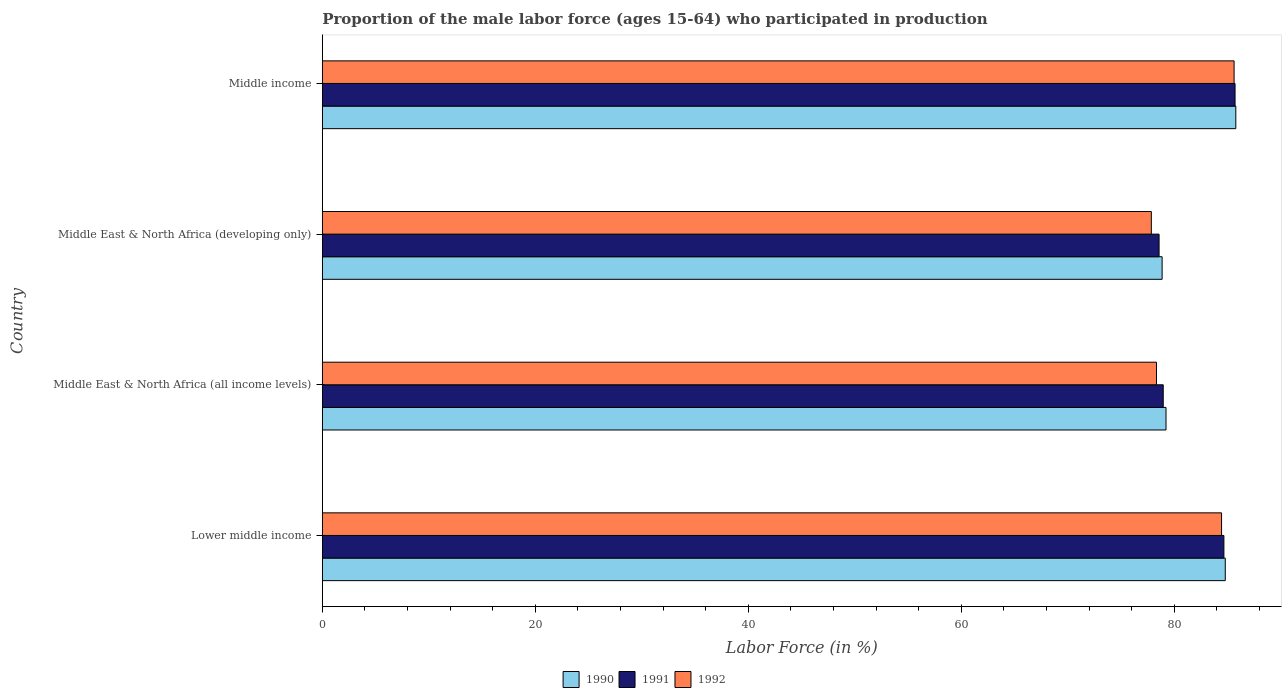How many different coloured bars are there?
Provide a succinct answer. 3. How many groups of bars are there?
Your answer should be compact. 4. Are the number of bars per tick equal to the number of legend labels?
Provide a succinct answer. Yes. Are the number of bars on each tick of the Y-axis equal?
Your response must be concise. Yes. How many bars are there on the 2nd tick from the bottom?
Give a very brief answer. 3. What is the label of the 2nd group of bars from the top?
Your answer should be compact. Middle East & North Africa (developing only). What is the proportion of the male labor force who participated in production in 1992 in Middle East & North Africa (developing only)?
Provide a succinct answer. 77.85. Across all countries, what is the maximum proportion of the male labor force who participated in production in 1990?
Offer a terse response. 85.78. Across all countries, what is the minimum proportion of the male labor force who participated in production in 1991?
Ensure brevity in your answer.  78.57. In which country was the proportion of the male labor force who participated in production in 1991 maximum?
Give a very brief answer. Middle income. In which country was the proportion of the male labor force who participated in production in 1992 minimum?
Your answer should be compact. Middle East & North Africa (developing only). What is the total proportion of the male labor force who participated in production in 1992 in the graph?
Give a very brief answer. 326.23. What is the difference between the proportion of the male labor force who participated in production in 1992 in Middle East & North Africa (all income levels) and that in Middle income?
Your answer should be compact. -7.29. What is the difference between the proportion of the male labor force who participated in production in 1991 in Middle income and the proportion of the male labor force who participated in production in 1992 in Middle East & North Africa (developing only)?
Keep it short and to the point. 7.86. What is the average proportion of the male labor force who participated in production in 1990 per country?
Make the answer very short. 82.16. What is the difference between the proportion of the male labor force who participated in production in 1992 and proportion of the male labor force who participated in production in 1990 in Middle East & North Africa (developing only)?
Your answer should be very brief. -1.01. What is the ratio of the proportion of the male labor force who participated in production in 1991 in Lower middle income to that in Middle East & North Africa (developing only)?
Ensure brevity in your answer.  1.08. What is the difference between the highest and the second highest proportion of the male labor force who participated in production in 1991?
Ensure brevity in your answer.  1.05. What is the difference between the highest and the lowest proportion of the male labor force who participated in production in 1991?
Your answer should be compact. 7.13. In how many countries, is the proportion of the male labor force who participated in production in 1992 greater than the average proportion of the male labor force who participated in production in 1992 taken over all countries?
Your answer should be very brief. 2. Is the sum of the proportion of the male labor force who participated in production in 1990 in Lower middle income and Middle East & North Africa (all income levels) greater than the maximum proportion of the male labor force who participated in production in 1991 across all countries?
Ensure brevity in your answer.  Yes. Are all the bars in the graph horizontal?
Make the answer very short. Yes. What is the difference between two consecutive major ticks on the X-axis?
Your answer should be very brief. 20. Does the graph contain any zero values?
Make the answer very short. No. Does the graph contain grids?
Your answer should be compact. No. Where does the legend appear in the graph?
Make the answer very short. Bottom center. How many legend labels are there?
Ensure brevity in your answer.  3. What is the title of the graph?
Offer a terse response. Proportion of the male labor force (ages 15-64) who participated in production. Does "1994" appear as one of the legend labels in the graph?
Provide a succinct answer. No. What is the label or title of the X-axis?
Your answer should be compact. Labor Force (in %). What is the label or title of the Y-axis?
Make the answer very short. Country. What is the Labor Force (in %) of 1990 in Lower middle income?
Offer a very short reply. 84.79. What is the Labor Force (in %) in 1991 in Lower middle income?
Your response must be concise. 84.66. What is the Labor Force (in %) in 1992 in Lower middle income?
Provide a succinct answer. 84.44. What is the Labor Force (in %) in 1990 in Middle East & North Africa (all income levels)?
Your answer should be very brief. 79.22. What is the Labor Force (in %) in 1991 in Middle East & North Africa (all income levels)?
Provide a succinct answer. 78.96. What is the Labor Force (in %) in 1992 in Middle East & North Africa (all income levels)?
Your answer should be very brief. 78.33. What is the Labor Force (in %) in 1990 in Middle East & North Africa (developing only)?
Make the answer very short. 78.86. What is the Labor Force (in %) in 1991 in Middle East & North Africa (developing only)?
Provide a short and direct response. 78.57. What is the Labor Force (in %) in 1992 in Middle East & North Africa (developing only)?
Your response must be concise. 77.85. What is the Labor Force (in %) of 1990 in Middle income?
Ensure brevity in your answer.  85.78. What is the Labor Force (in %) of 1991 in Middle income?
Your answer should be very brief. 85.71. What is the Labor Force (in %) of 1992 in Middle income?
Offer a very short reply. 85.62. Across all countries, what is the maximum Labor Force (in %) of 1990?
Ensure brevity in your answer.  85.78. Across all countries, what is the maximum Labor Force (in %) in 1991?
Offer a terse response. 85.71. Across all countries, what is the maximum Labor Force (in %) of 1992?
Give a very brief answer. 85.62. Across all countries, what is the minimum Labor Force (in %) in 1990?
Ensure brevity in your answer.  78.86. Across all countries, what is the minimum Labor Force (in %) of 1991?
Your response must be concise. 78.57. Across all countries, what is the minimum Labor Force (in %) of 1992?
Your answer should be very brief. 77.85. What is the total Labor Force (in %) of 1990 in the graph?
Your answer should be very brief. 328.65. What is the total Labor Force (in %) of 1991 in the graph?
Offer a very short reply. 327.9. What is the total Labor Force (in %) of 1992 in the graph?
Provide a short and direct response. 326.23. What is the difference between the Labor Force (in %) in 1990 in Lower middle income and that in Middle East & North Africa (all income levels)?
Your answer should be very brief. 5.56. What is the difference between the Labor Force (in %) of 1991 in Lower middle income and that in Middle East & North Africa (all income levels)?
Make the answer very short. 5.7. What is the difference between the Labor Force (in %) in 1992 in Lower middle income and that in Middle East & North Africa (all income levels)?
Provide a succinct answer. 6.11. What is the difference between the Labor Force (in %) in 1990 in Lower middle income and that in Middle East & North Africa (developing only)?
Give a very brief answer. 5.93. What is the difference between the Labor Force (in %) in 1991 in Lower middle income and that in Middle East & North Africa (developing only)?
Provide a short and direct response. 6.09. What is the difference between the Labor Force (in %) in 1992 in Lower middle income and that in Middle East & North Africa (developing only)?
Your answer should be compact. 6.59. What is the difference between the Labor Force (in %) of 1990 in Lower middle income and that in Middle income?
Make the answer very short. -0.99. What is the difference between the Labor Force (in %) in 1991 in Lower middle income and that in Middle income?
Your answer should be compact. -1.05. What is the difference between the Labor Force (in %) of 1992 in Lower middle income and that in Middle income?
Your response must be concise. -1.18. What is the difference between the Labor Force (in %) of 1990 in Middle East & North Africa (all income levels) and that in Middle East & North Africa (developing only)?
Give a very brief answer. 0.37. What is the difference between the Labor Force (in %) in 1991 in Middle East & North Africa (all income levels) and that in Middle East & North Africa (developing only)?
Offer a very short reply. 0.39. What is the difference between the Labor Force (in %) in 1992 in Middle East & North Africa (all income levels) and that in Middle East & North Africa (developing only)?
Your response must be concise. 0.48. What is the difference between the Labor Force (in %) of 1990 in Middle East & North Africa (all income levels) and that in Middle income?
Your answer should be compact. -6.55. What is the difference between the Labor Force (in %) of 1991 in Middle East & North Africa (all income levels) and that in Middle income?
Your response must be concise. -6.74. What is the difference between the Labor Force (in %) of 1992 in Middle East & North Africa (all income levels) and that in Middle income?
Provide a succinct answer. -7.29. What is the difference between the Labor Force (in %) of 1990 in Middle East & North Africa (developing only) and that in Middle income?
Give a very brief answer. -6.92. What is the difference between the Labor Force (in %) of 1991 in Middle East & North Africa (developing only) and that in Middle income?
Provide a succinct answer. -7.13. What is the difference between the Labor Force (in %) of 1992 in Middle East & North Africa (developing only) and that in Middle income?
Keep it short and to the point. -7.77. What is the difference between the Labor Force (in %) in 1990 in Lower middle income and the Labor Force (in %) in 1991 in Middle East & North Africa (all income levels)?
Your response must be concise. 5.82. What is the difference between the Labor Force (in %) of 1990 in Lower middle income and the Labor Force (in %) of 1992 in Middle East & North Africa (all income levels)?
Ensure brevity in your answer.  6.46. What is the difference between the Labor Force (in %) of 1991 in Lower middle income and the Labor Force (in %) of 1992 in Middle East & North Africa (all income levels)?
Offer a very short reply. 6.33. What is the difference between the Labor Force (in %) in 1990 in Lower middle income and the Labor Force (in %) in 1991 in Middle East & North Africa (developing only)?
Provide a short and direct response. 6.22. What is the difference between the Labor Force (in %) in 1990 in Lower middle income and the Labor Force (in %) in 1992 in Middle East & North Africa (developing only)?
Provide a succinct answer. 6.94. What is the difference between the Labor Force (in %) in 1991 in Lower middle income and the Labor Force (in %) in 1992 in Middle East & North Africa (developing only)?
Provide a succinct answer. 6.81. What is the difference between the Labor Force (in %) of 1990 in Lower middle income and the Labor Force (in %) of 1991 in Middle income?
Provide a succinct answer. -0.92. What is the difference between the Labor Force (in %) in 1990 in Lower middle income and the Labor Force (in %) in 1992 in Middle income?
Give a very brief answer. -0.83. What is the difference between the Labor Force (in %) of 1991 in Lower middle income and the Labor Force (in %) of 1992 in Middle income?
Ensure brevity in your answer.  -0.96. What is the difference between the Labor Force (in %) of 1990 in Middle East & North Africa (all income levels) and the Labor Force (in %) of 1991 in Middle East & North Africa (developing only)?
Your answer should be very brief. 0.65. What is the difference between the Labor Force (in %) of 1990 in Middle East & North Africa (all income levels) and the Labor Force (in %) of 1992 in Middle East & North Africa (developing only)?
Provide a succinct answer. 1.38. What is the difference between the Labor Force (in %) of 1991 in Middle East & North Africa (all income levels) and the Labor Force (in %) of 1992 in Middle East & North Africa (developing only)?
Offer a terse response. 1.12. What is the difference between the Labor Force (in %) in 1990 in Middle East & North Africa (all income levels) and the Labor Force (in %) in 1991 in Middle income?
Ensure brevity in your answer.  -6.48. What is the difference between the Labor Force (in %) in 1990 in Middle East & North Africa (all income levels) and the Labor Force (in %) in 1992 in Middle income?
Your answer should be very brief. -6.39. What is the difference between the Labor Force (in %) of 1991 in Middle East & North Africa (all income levels) and the Labor Force (in %) of 1992 in Middle income?
Offer a very short reply. -6.65. What is the difference between the Labor Force (in %) of 1990 in Middle East & North Africa (developing only) and the Labor Force (in %) of 1991 in Middle income?
Your response must be concise. -6.85. What is the difference between the Labor Force (in %) in 1990 in Middle East & North Africa (developing only) and the Labor Force (in %) in 1992 in Middle income?
Provide a succinct answer. -6.76. What is the difference between the Labor Force (in %) in 1991 in Middle East & North Africa (developing only) and the Labor Force (in %) in 1992 in Middle income?
Your response must be concise. -7.04. What is the average Labor Force (in %) of 1990 per country?
Keep it short and to the point. 82.16. What is the average Labor Force (in %) in 1991 per country?
Keep it short and to the point. 81.98. What is the average Labor Force (in %) of 1992 per country?
Your answer should be compact. 81.56. What is the difference between the Labor Force (in %) in 1990 and Labor Force (in %) in 1991 in Lower middle income?
Provide a succinct answer. 0.13. What is the difference between the Labor Force (in %) in 1990 and Labor Force (in %) in 1992 in Lower middle income?
Your answer should be compact. 0.35. What is the difference between the Labor Force (in %) of 1991 and Labor Force (in %) of 1992 in Lower middle income?
Give a very brief answer. 0.22. What is the difference between the Labor Force (in %) in 1990 and Labor Force (in %) in 1991 in Middle East & North Africa (all income levels)?
Ensure brevity in your answer.  0.26. What is the difference between the Labor Force (in %) of 1990 and Labor Force (in %) of 1992 in Middle East & North Africa (all income levels)?
Your answer should be compact. 0.89. What is the difference between the Labor Force (in %) of 1991 and Labor Force (in %) of 1992 in Middle East & North Africa (all income levels)?
Make the answer very short. 0.63. What is the difference between the Labor Force (in %) of 1990 and Labor Force (in %) of 1991 in Middle East & North Africa (developing only)?
Offer a very short reply. 0.29. What is the difference between the Labor Force (in %) of 1990 and Labor Force (in %) of 1992 in Middle East & North Africa (developing only)?
Provide a succinct answer. 1.01. What is the difference between the Labor Force (in %) in 1991 and Labor Force (in %) in 1992 in Middle East & North Africa (developing only)?
Make the answer very short. 0.73. What is the difference between the Labor Force (in %) in 1990 and Labor Force (in %) in 1991 in Middle income?
Your answer should be compact. 0.07. What is the difference between the Labor Force (in %) of 1990 and Labor Force (in %) of 1992 in Middle income?
Your answer should be compact. 0.16. What is the difference between the Labor Force (in %) of 1991 and Labor Force (in %) of 1992 in Middle income?
Provide a short and direct response. 0.09. What is the ratio of the Labor Force (in %) of 1990 in Lower middle income to that in Middle East & North Africa (all income levels)?
Give a very brief answer. 1.07. What is the ratio of the Labor Force (in %) in 1991 in Lower middle income to that in Middle East & North Africa (all income levels)?
Provide a succinct answer. 1.07. What is the ratio of the Labor Force (in %) of 1992 in Lower middle income to that in Middle East & North Africa (all income levels)?
Your answer should be very brief. 1.08. What is the ratio of the Labor Force (in %) of 1990 in Lower middle income to that in Middle East & North Africa (developing only)?
Provide a short and direct response. 1.08. What is the ratio of the Labor Force (in %) of 1991 in Lower middle income to that in Middle East & North Africa (developing only)?
Offer a terse response. 1.08. What is the ratio of the Labor Force (in %) of 1992 in Lower middle income to that in Middle East & North Africa (developing only)?
Provide a short and direct response. 1.08. What is the ratio of the Labor Force (in %) of 1990 in Lower middle income to that in Middle income?
Offer a very short reply. 0.99. What is the ratio of the Labor Force (in %) of 1992 in Lower middle income to that in Middle income?
Make the answer very short. 0.99. What is the ratio of the Labor Force (in %) in 1990 in Middle East & North Africa (all income levels) to that in Middle East & North Africa (developing only)?
Ensure brevity in your answer.  1. What is the ratio of the Labor Force (in %) of 1991 in Middle East & North Africa (all income levels) to that in Middle East & North Africa (developing only)?
Give a very brief answer. 1. What is the ratio of the Labor Force (in %) in 1990 in Middle East & North Africa (all income levels) to that in Middle income?
Make the answer very short. 0.92. What is the ratio of the Labor Force (in %) in 1991 in Middle East & North Africa (all income levels) to that in Middle income?
Your response must be concise. 0.92. What is the ratio of the Labor Force (in %) of 1992 in Middle East & North Africa (all income levels) to that in Middle income?
Your answer should be compact. 0.91. What is the ratio of the Labor Force (in %) in 1990 in Middle East & North Africa (developing only) to that in Middle income?
Provide a succinct answer. 0.92. What is the ratio of the Labor Force (in %) of 1991 in Middle East & North Africa (developing only) to that in Middle income?
Your response must be concise. 0.92. What is the ratio of the Labor Force (in %) of 1992 in Middle East & North Africa (developing only) to that in Middle income?
Make the answer very short. 0.91. What is the difference between the highest and the second highest Labor Force (in %) in 1990?
Make the answer very short. 0.99. What is the difference between the highest and the second highest Labor Force (in %) of 1991?
Your answer should be compact. 1.05. What is the difference between the highest and the second highest Labor Force (in %) of 1992?
Provide a short and direct response. 1.18. What is the difference between the highest and the lowest Labor Force (in %) in 1990?
Make the answer very short. 6.92. What is the difference between the highest and the lowest Labor Force (in %) of 1991?
Offer a terse response. 7.13. What is the difference between the highest and the lowest Labor Force (in %) of 1992?
Keep it short and to the point. 7.77. 